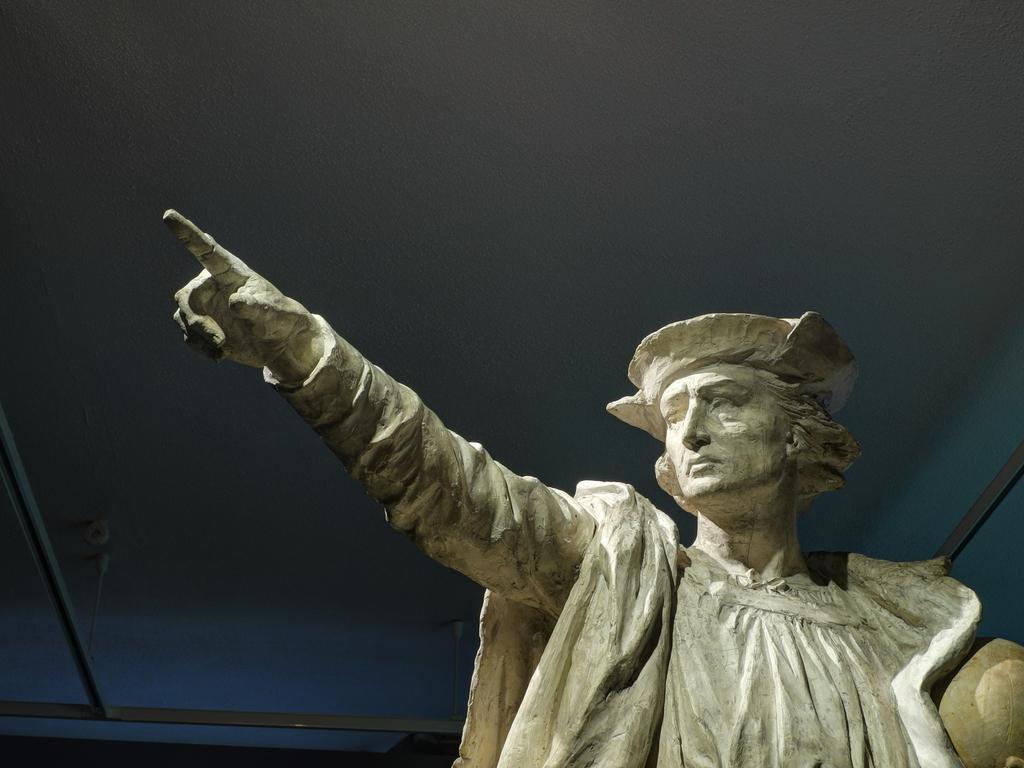Please provide a concise description of this image. In the center of the image we can see one statue. In the background there is a wall and a few other objects. 